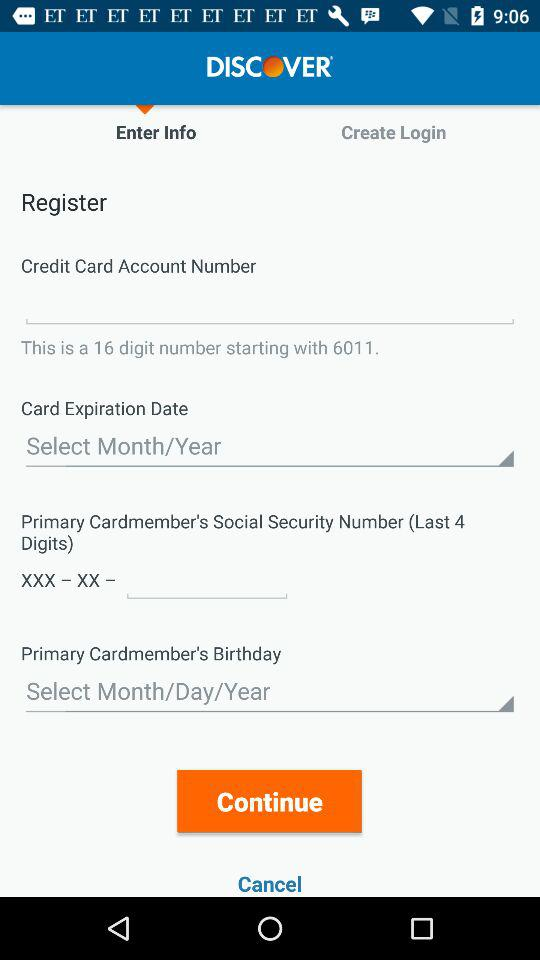What is the social security number?
When the provided information is insufficient, respond with <no answer>. <no answer> 